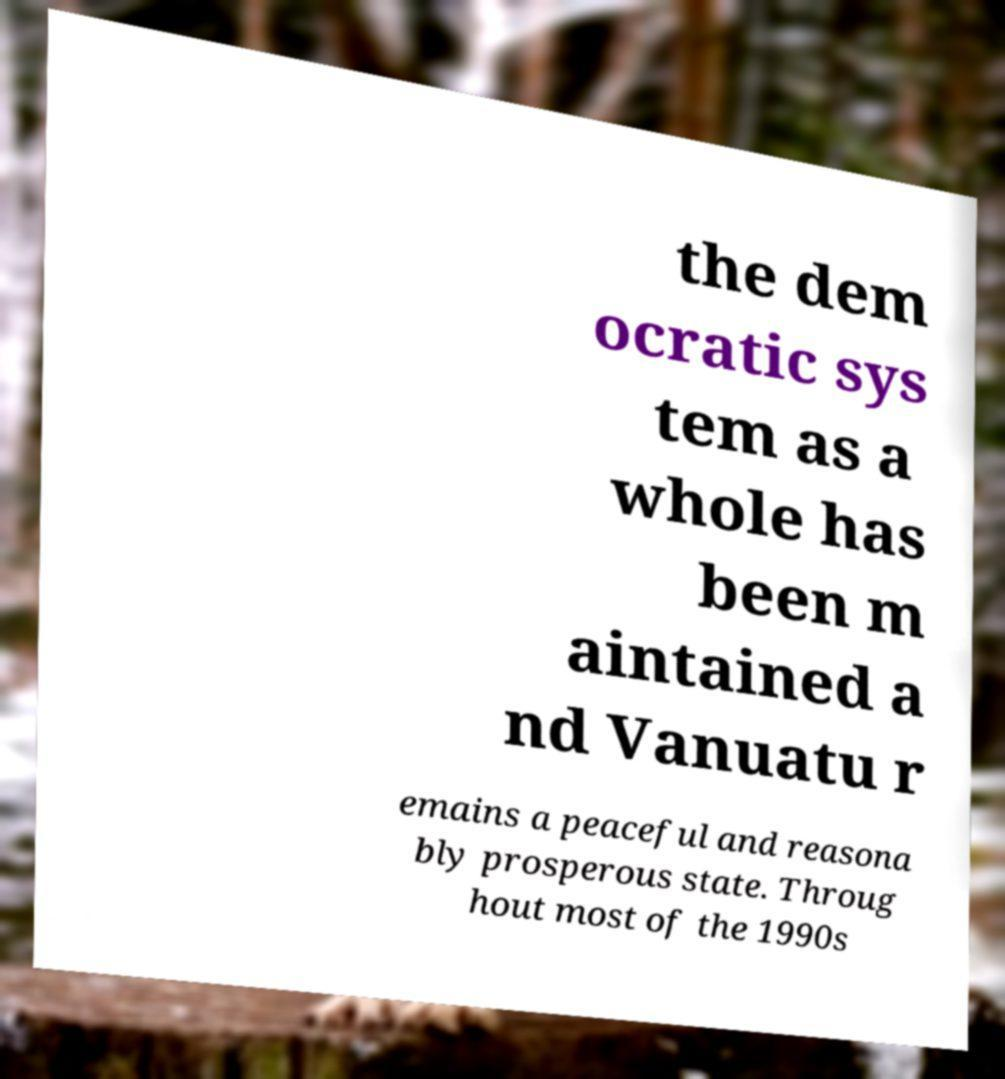Can you read and provide the text displayed in the image?This photo seems to have some interesting text. Can you extract and type it out for me? the dem ocratic sys tem as a whole has been m aintained a nd Vanuatu r emains a peaceful and reasona bly prosperous state. Throug hout most of the 1990s 